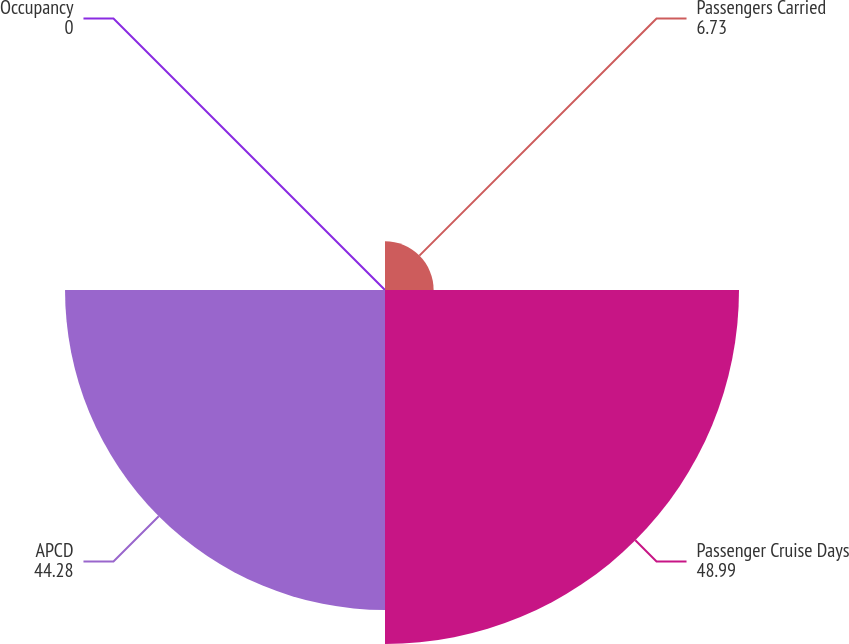<chart> <loc_0><loc_0><loc_500><loc_500><pie_chart><fcel>Passengers Carried<fcel>Passenger Cruise Days<fcel>APCD<fcel>Occupancy<nl><fcel>6.73%<fcel>48.99%<fcel>44.28%<fcel>0.0%<nl></chart> 